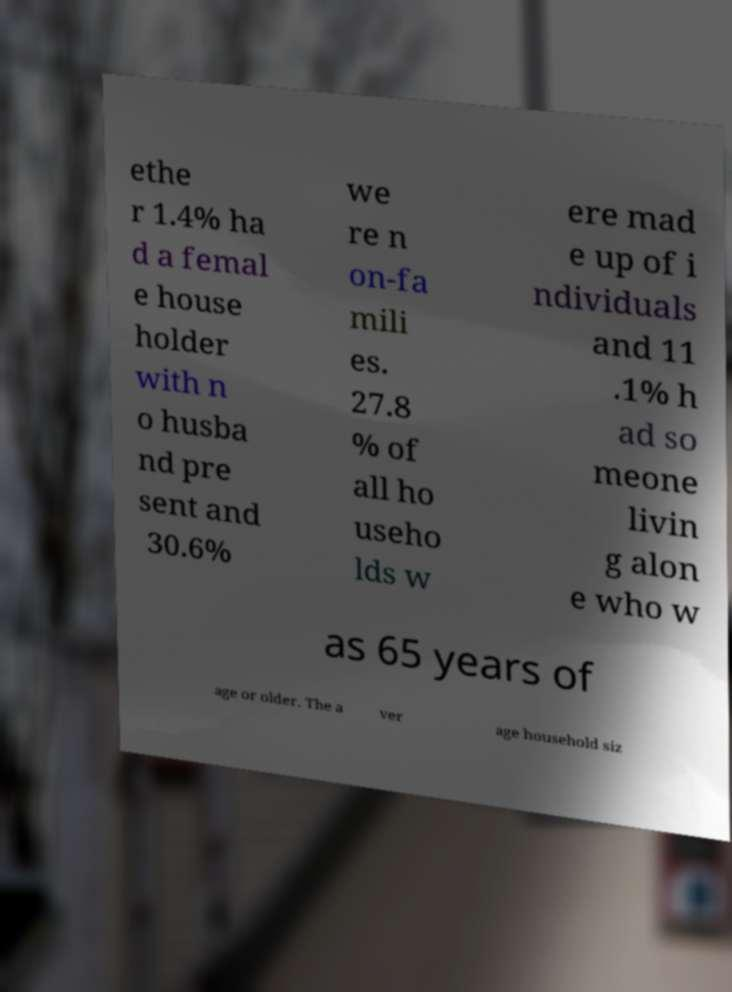There's text embedded in this image that I need extracted. Can you transcribe it verbatim? ethe r 1.4% ha d a femal e house holder with n o husba nd pre sent and 30.6% we re n on-fa mili es. 27.8 % of all ho useho lds w ere mad e up of i ndividuals and 11 .1% h ad so meone livin g alon e who w as 65 years of age or older. The a ver age household siz 